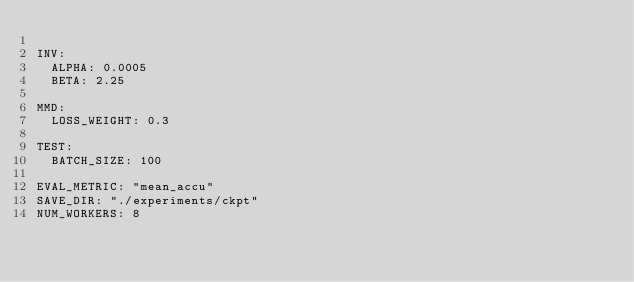Convert code to text. <code><loc_0><loc_0><loc_500><loc_500><_YAML_>
INV:
  ALPHA: 0.0005
  BETA: 2.25

MMD:
  LOSS_WEIGHT: 0.3

TEST:
  BATCH_SIZE: 100

EVAL_METRIC: "mean_accu"
SAVE_DIR: "./experiments/ckpt"
NUM_WORKERS: 8
</code> 